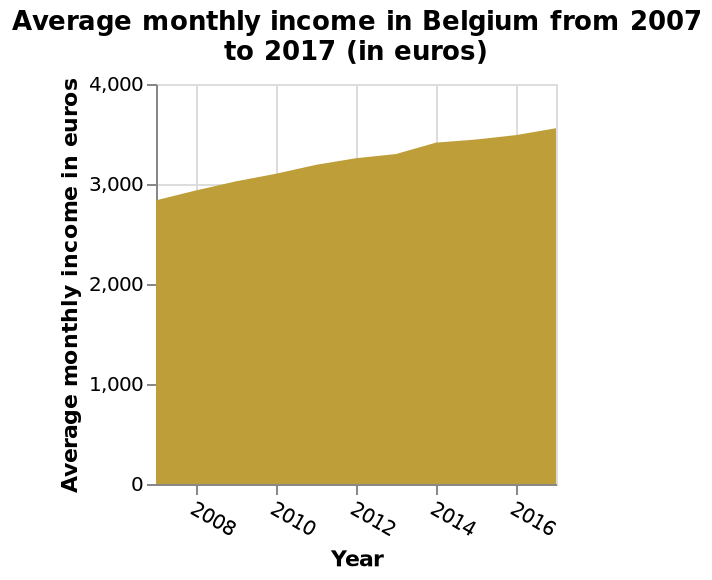<image>
What is the scale used on the x-axis of the area chart?  The x-axis of the area chart uses a linear scale representing years. By how much did the average monthly income in Belgium increase between 2008 and 2016? The average monthly income in Belgium increased by more than 3000 euros between 2008 and 2016. What is plotted on the y-axis of the area chart?  The y-axis of the area chart represents the "Average monthly income in euros." 